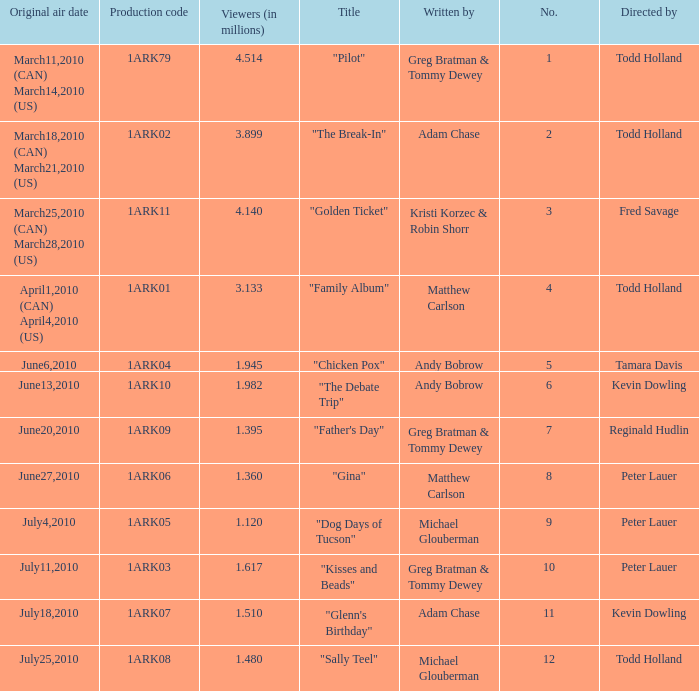List all who wrote for production code 1ark07. Adam Chase. 